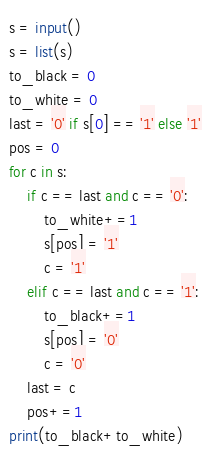Convert code to text. <code><loc_0><loc_0><loc_500><loc_500><_Python_>s = input()
s = list(s)
to_black = 0
to_white = 0
last = '0' if s[0] == '1' else '1'
pos = 0
for c in s:
    if c == last and c == '0':
        to_white+=1
        s[pos] = '1'
        c = '1'
    elif c == last and c == '1':
        to_black+=1
        s[pos] = '0'
        c = '0'
    last = c
    pos+=1
print(to_black+to_white)</code> 